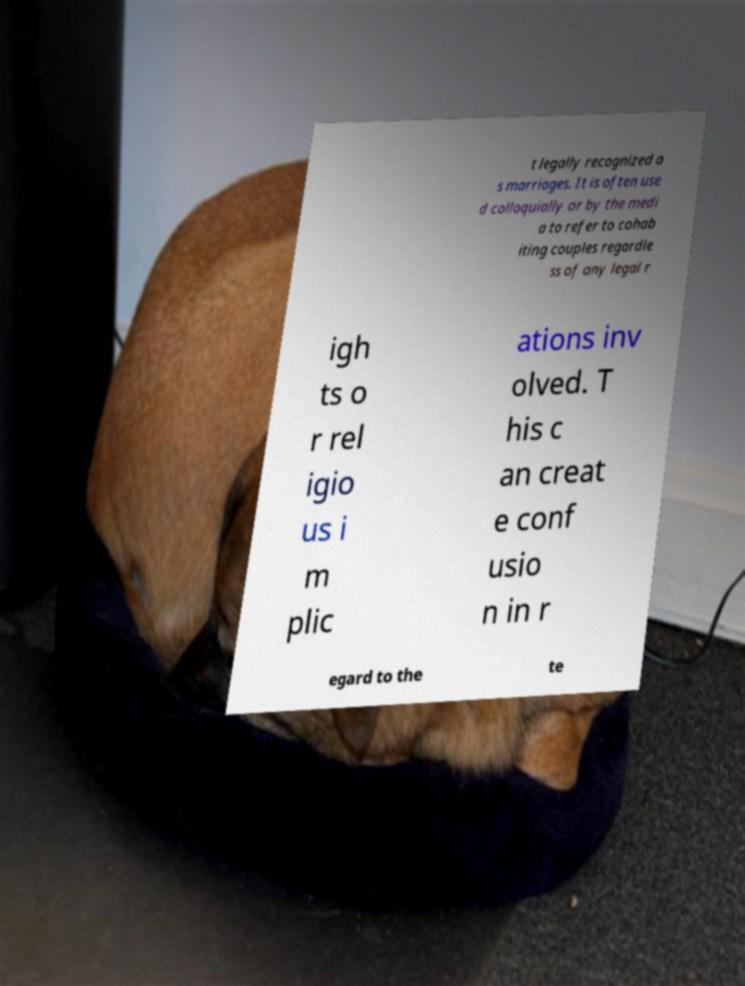What messages or text are displayed in this image? I need them in a readable, typed format. t legally recognized a s marriages. It is often use d colloquially or by the medi a to refer to cohab iting couples regardle ss of any legal r igh ts o r rel igio us i m plic ations inv olved. T his c an creat e conf usio n in r egard to the te 